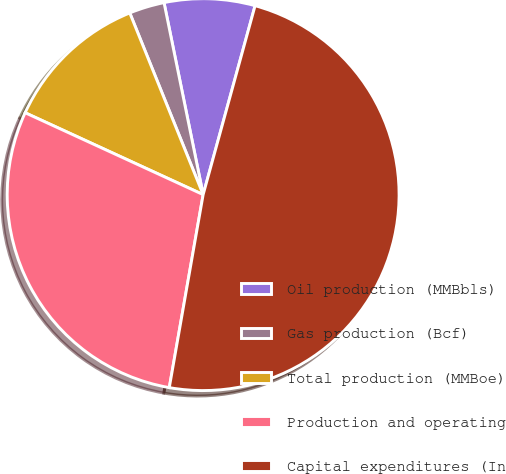Convert chart. <chart><loc_0><loc_0><loc_500><loc_500><pie_chart><fcel>Oil production (MMBbls)<fcel>Gas production (Bcf)<fcel>Total production (MMBoe)<fcel>Production and operating<fcel>Capital expenditures (In<nl><fcel>7.47%<fcel>2.91%<fcel>12.03%<fcel>29.1%<fcel>48.5%<nl></chart> 